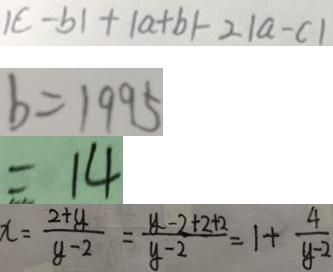<formula> <loc_0><loc_0><loc_500><loc_500>\vert c - b \vert + \vert a + b \vert - 2 \vert a - c \vert 
 b = 1 9 9 5 
 = 1 4 
 x = \frac { 2 + y } { y - 2 } = \frac { y - 2 + 2 + 2 } { y - 2 } = 1 + \frac { 4 } { y - 2 }</formula> 